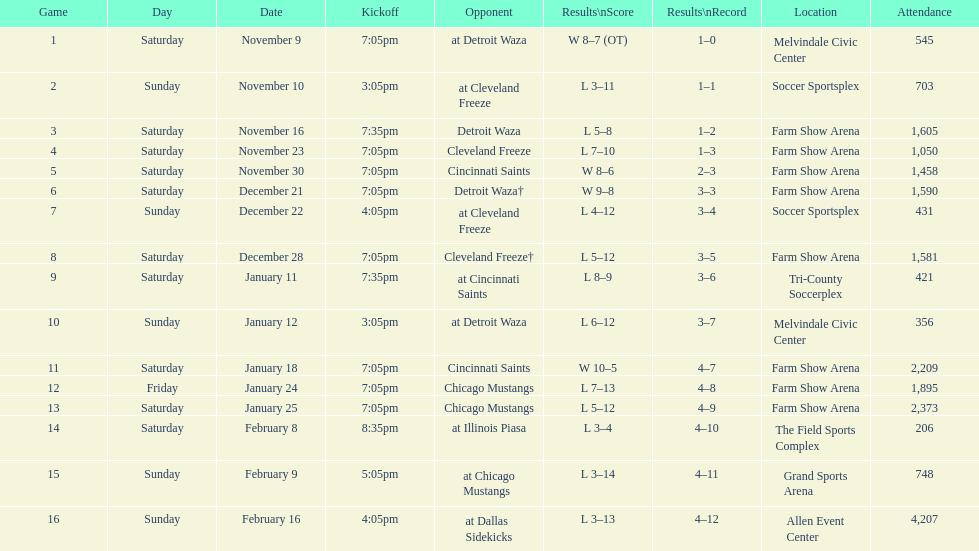In total, how many games were lost by the harrisburg heat to the cleveland freeze? 4. 